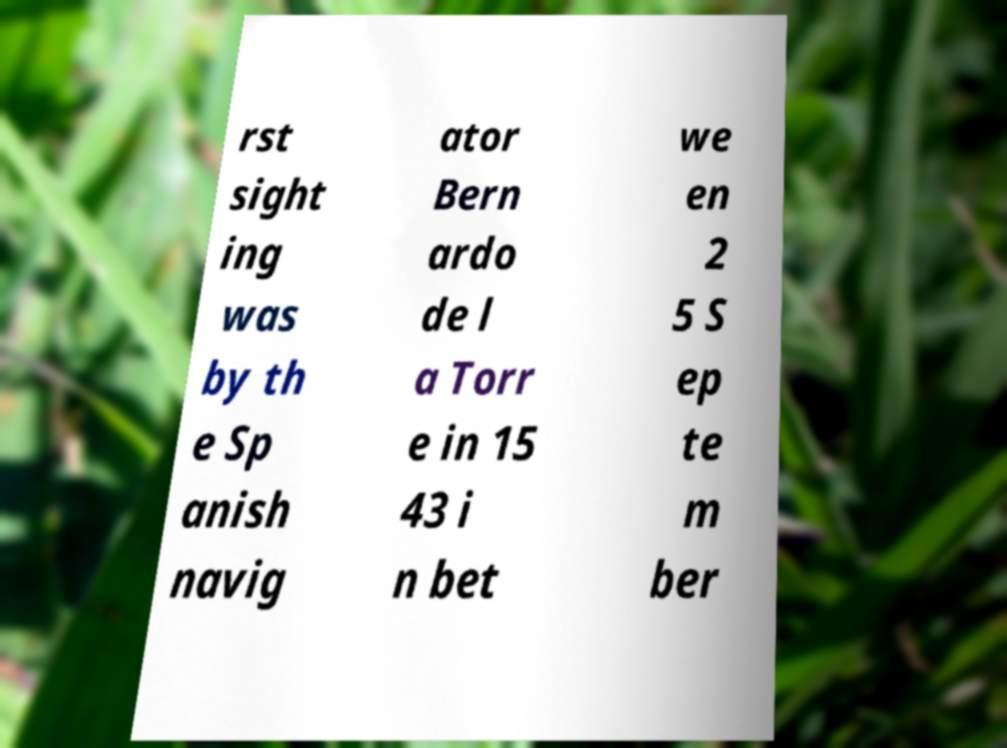For documentation purposes, I need the text within this image transcribed. Could you provide that? rst sight ing was by th e Sp anish navig ator Bern ardo de l a Torr e in 15 43 i n bet we en 2 5 S ep te m ber 